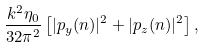Convert formula to latex. <formula><loc_0><loc_0><loc_500><loc_500>\frac { k ^ { 2 } \eta _ { 0 } } { 3 2 \pi ^ { 2 } } \left [ | p _ { y } ( n ) | ^ { 2 } + | p _ { z } ( n ) | ^ { 2 } \right ] ,</formula> 